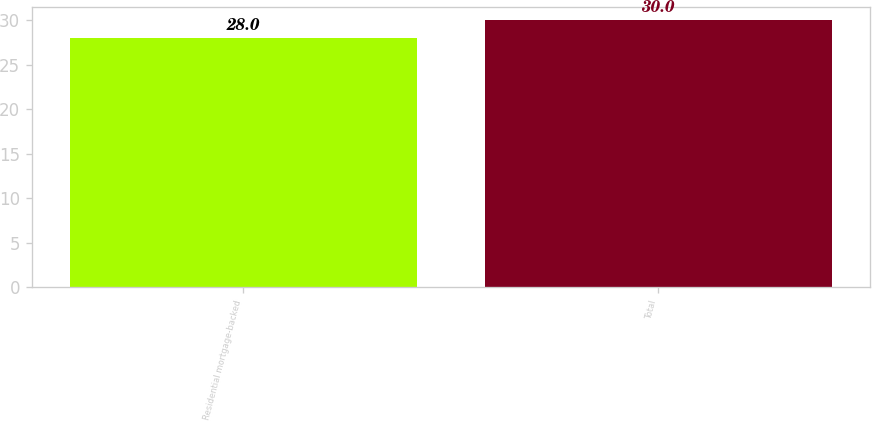<chart> <loc_0><loc_0><loc_500><loc_500><bar_chart><fcel>Residential mortgage-backed<fcel>Total<nl><fcel>28<fcel>30<nl></chart> 